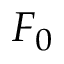Convert formula to latex. <formula><loc_0><loc_0><loc_500><loc_500>F _ { 0 }</formula> 